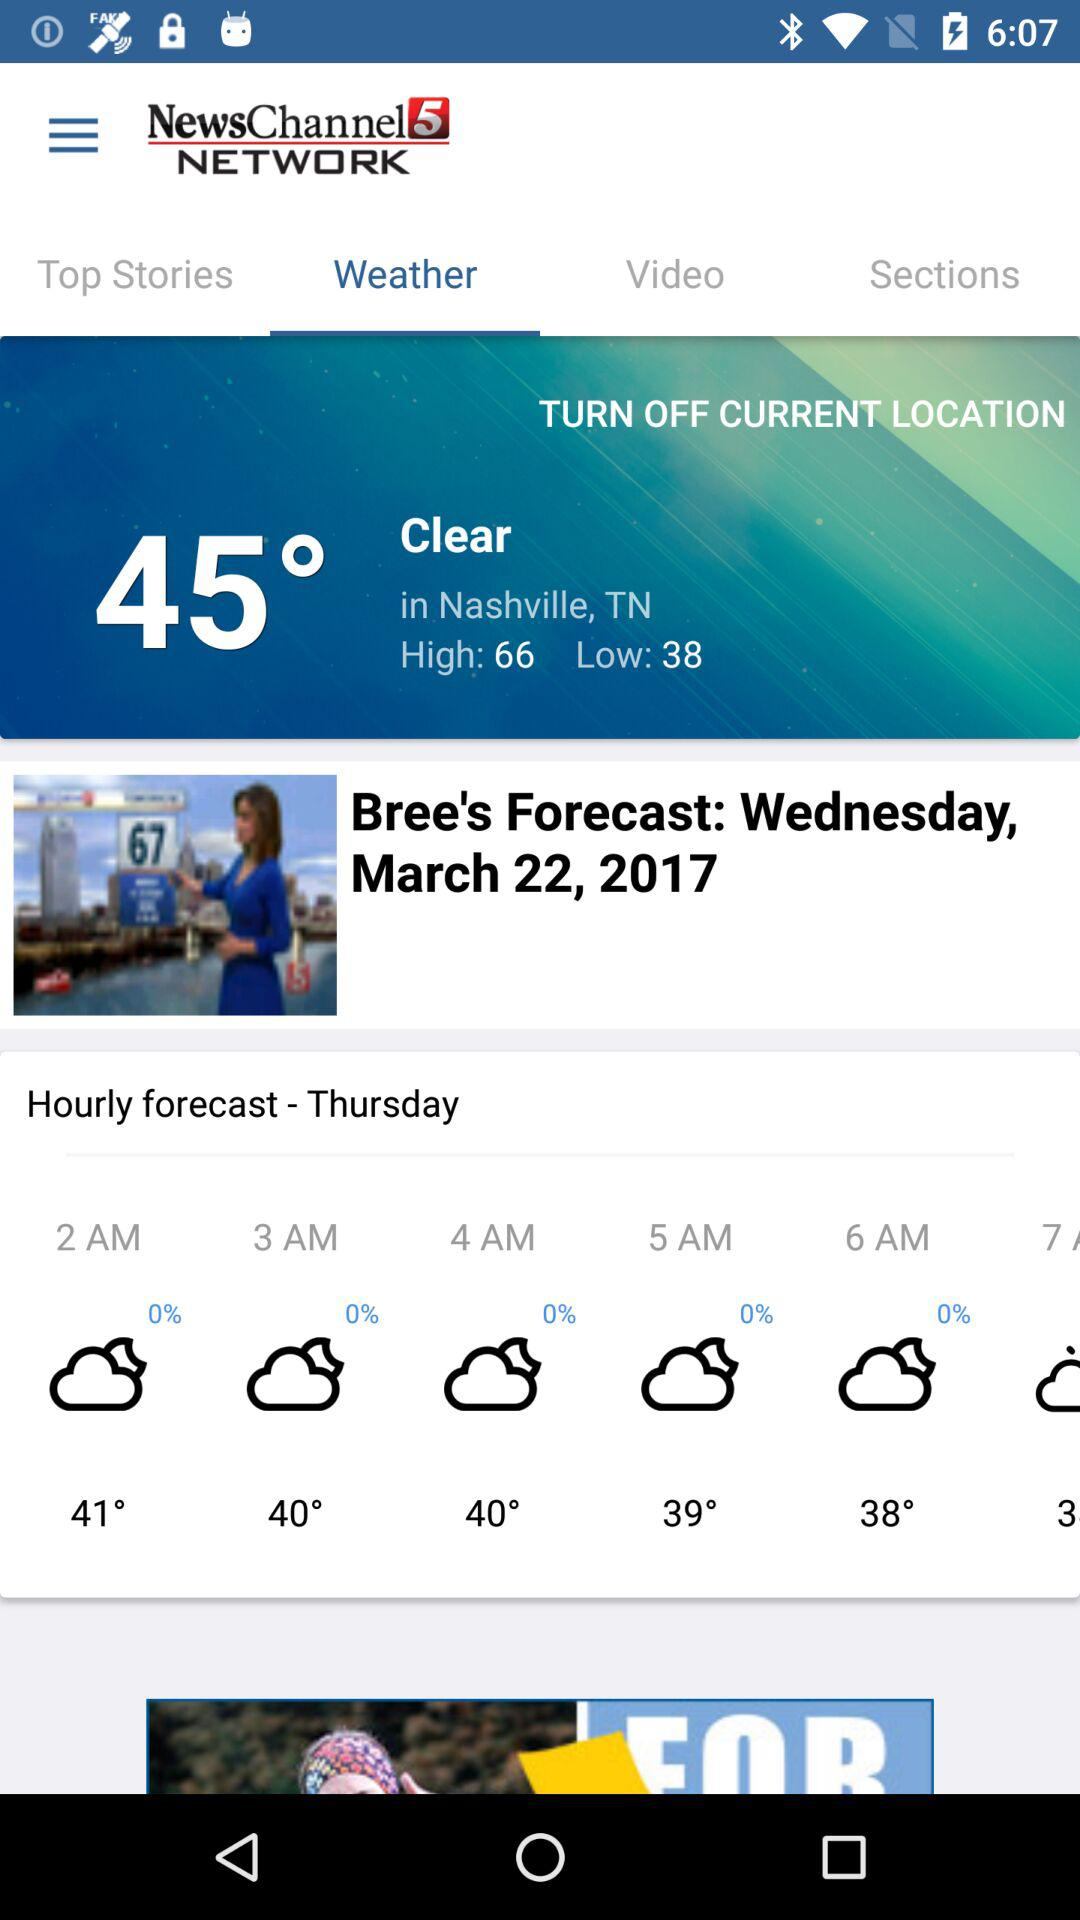What is the day on March 22, 2017? The day is Wednesday. 